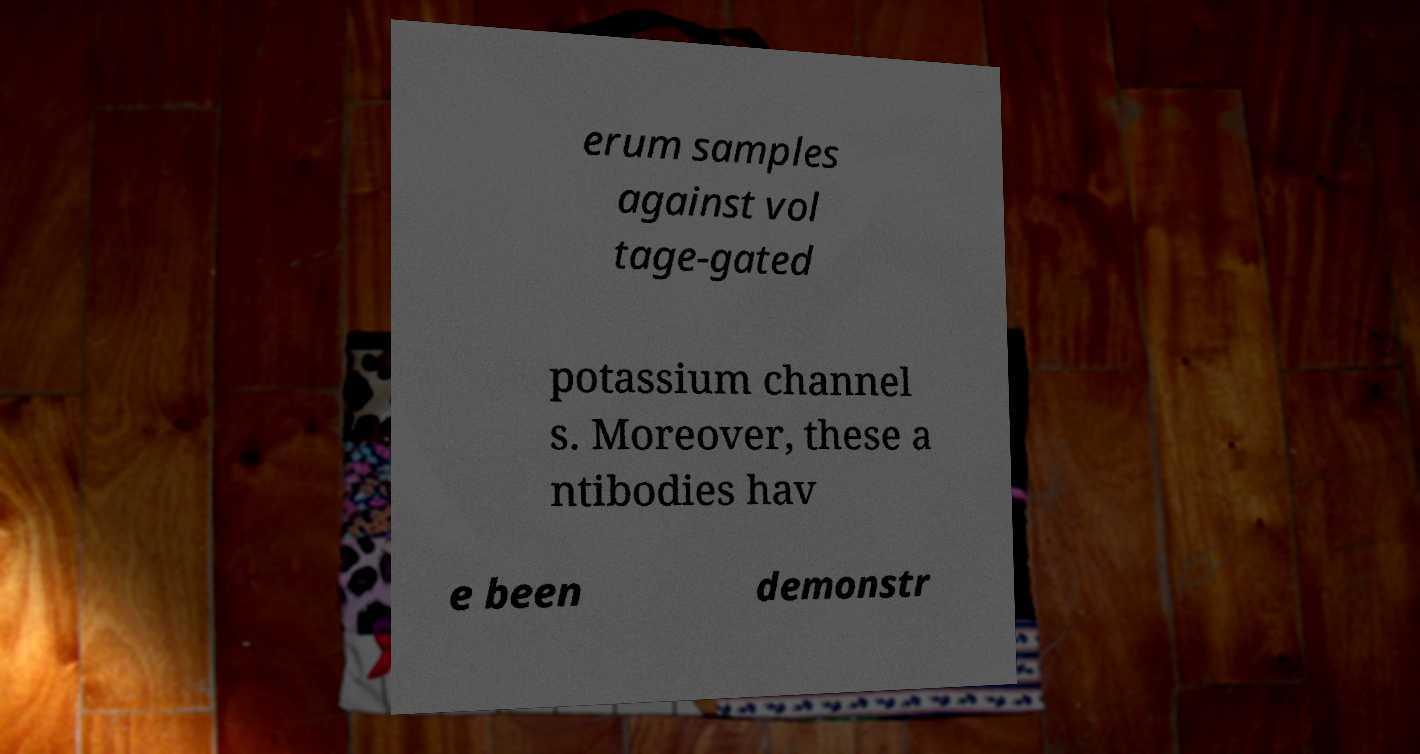What messages or text are displayed in this image? I need them in a readable, typed format. erum samples against vol tage-gated potassium channel s. Moreover, these a ntibodies hav e been demonstr 